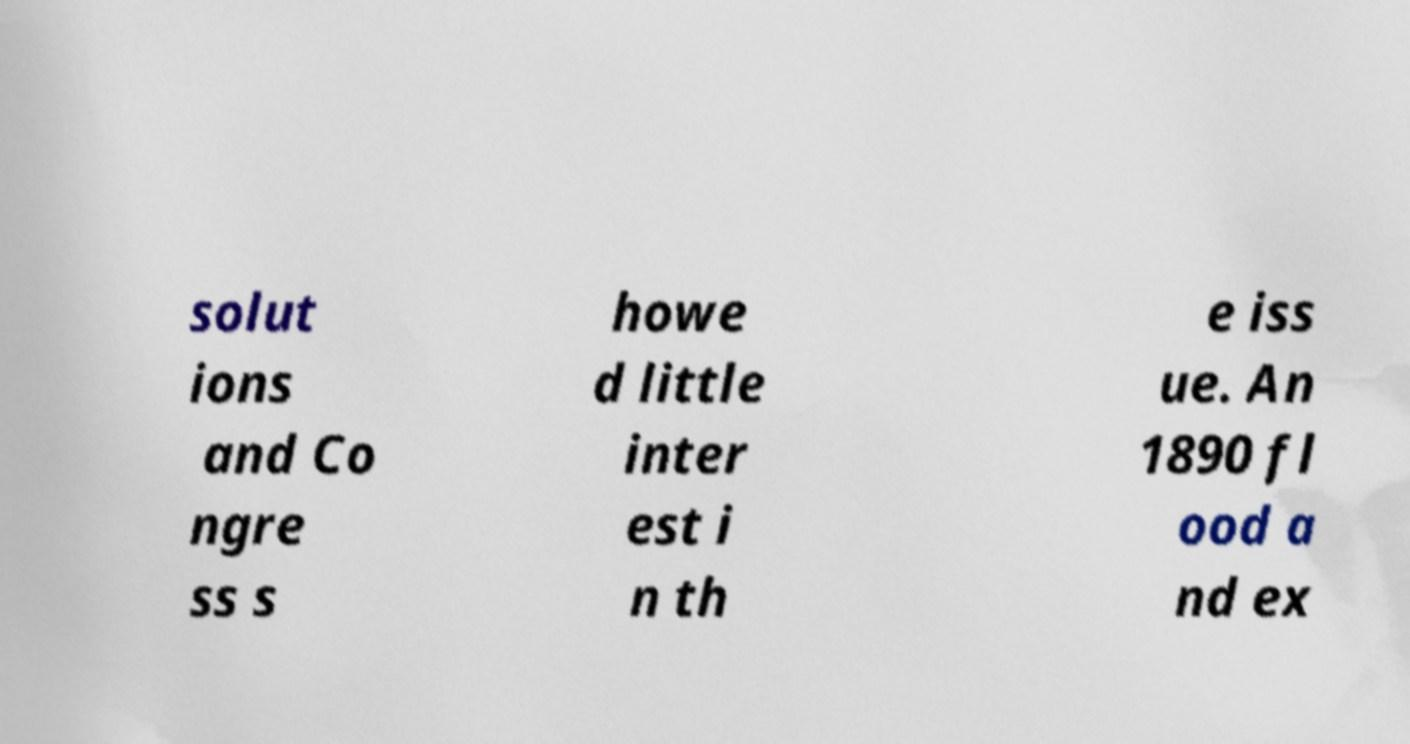I need the written content from this picture converted into text. Can you do that? solut ions and Co ngre ss s howe d little inter est i n th e iss ue. An 1890 fl ood a nd ex 